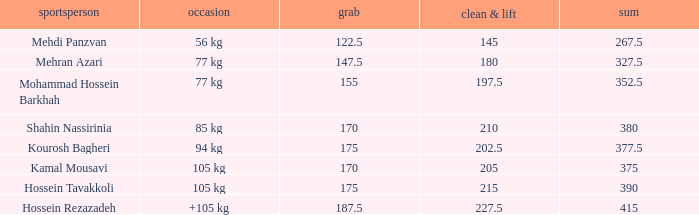What is the lowest total that had less than 170 snatches, 56 kg events and less than 145 clean & jerk? None. 